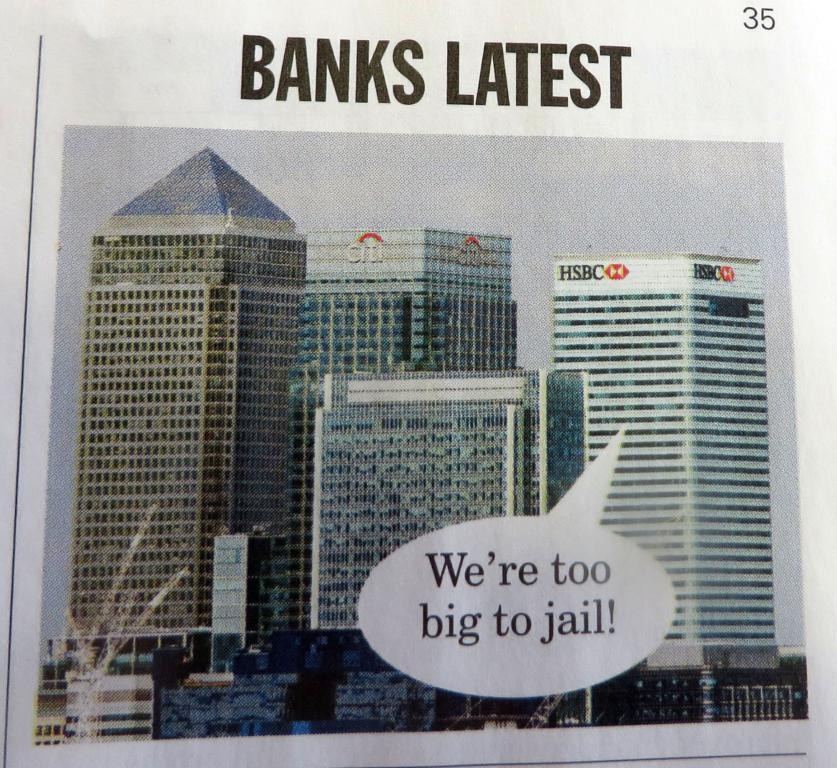What is the main subject of the image? The main subject of the image is a book cover. What can be seen on the book cover? The book cover has a picture of buildings. Is there any text on the book cover? Yes, there is some text at the top of the image. What type of punishment is being administered to the patient in the hospital in the image? There is no hospital or patient present in the image; it features a book cover with a picture of buildings and some text. 